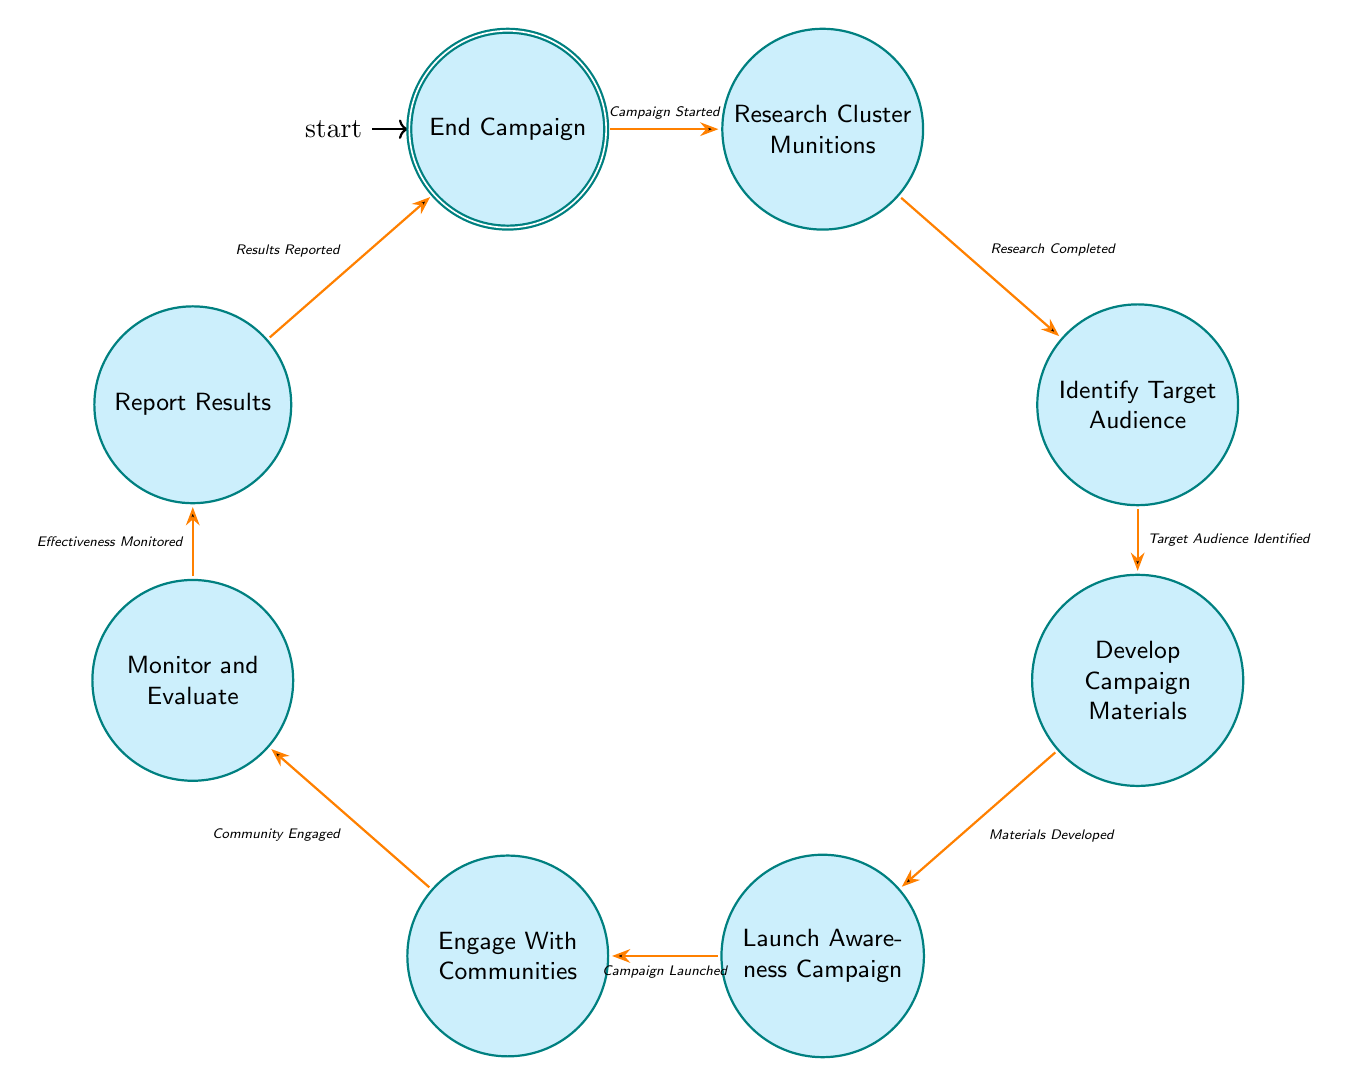What is the initial state of the campaign? The initial state is represented in the diagram as "Start Campaign," where the campaign is conceptualized.
Answer: Start Campaign How many states are in the campaign workflow? By counting the nodes in the diagram, there are a total of 9 states represented.
Answer: 9 What is the transition condition from "Launch Awareness Campaign" to "Engage With Communities"? From "Launch Awareness Campaign," the transition to "Engage With Communities" occurs under the condition "Campaign Launched."
Answer: Campaign Launched What state follows "Monitor and Evaluate"? The state that directly follows "Monitor and Evaluate" in the workflow is "Report Results."
Answer: Report Results What is the final state of the workflow? The diagram concludes with a state labeled "End Campaign," which signifies the conclusion of the campaign process.
Answer: End Campaign What states require community engagement feedback? The states that specifically involve community engagement feedback are "Engage With Communities" and "Monitor and Evaluate."
Answer: Engage With Communities, Monitor and Evaluate How do you transition from "Research Cluster Munitions" to "Identify Target Audience"? To transition from "Research Cluster Munitions" to "Identify Target Audience," the condition must be met that "Research Completed."
Answer: Research Completed Which state involves creating educational content? The state in which educational content is created is "Develop Campaign Materials."
Answer: Develop Campaign Materials What must happen before launching the awareness campaign? Before launching the awareness campaign, the "Materials Developed" condition must be fulfilled in the previous state.
Answer: Materials Developed 